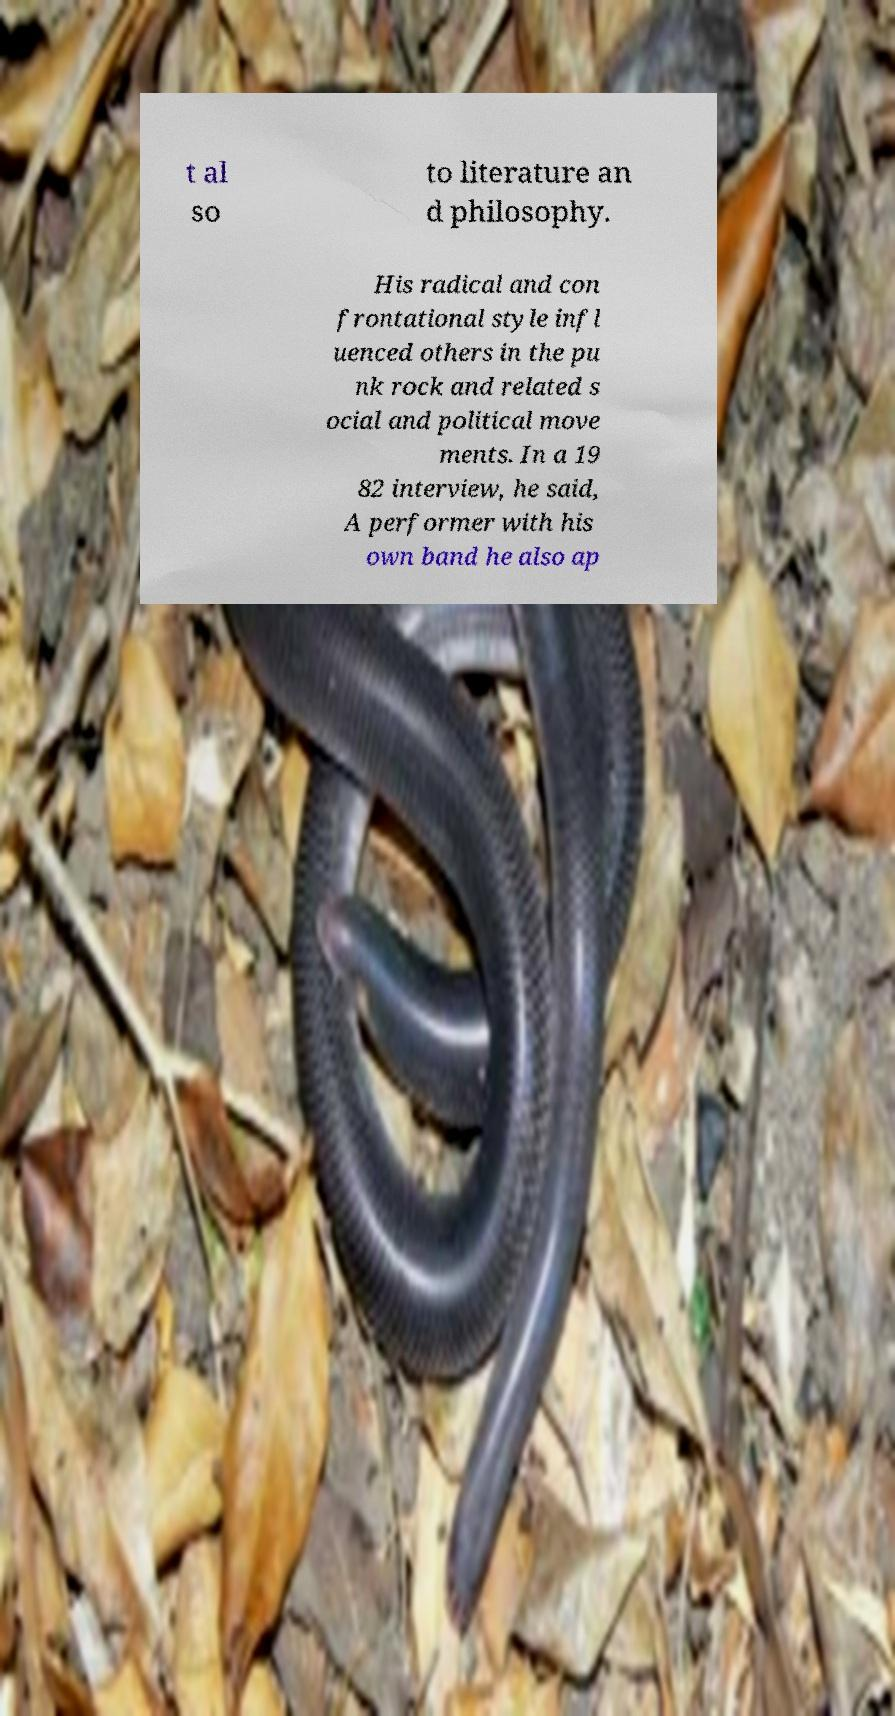For documentation purposes, I need the text within this image transcribed. Could you provide that? t al so to literature an d philosophy. His radical and con frontational style infl uenced others in the pu nk rock and related s ocial and political move ments. In a 19 82 interview, he said, A performer with his own band he also ap 